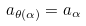<formula> <loc_0><loc_0><loc_500><loc_500>a _ { \theta ( \alpha ) } = a _ { \alpha }</formula> 